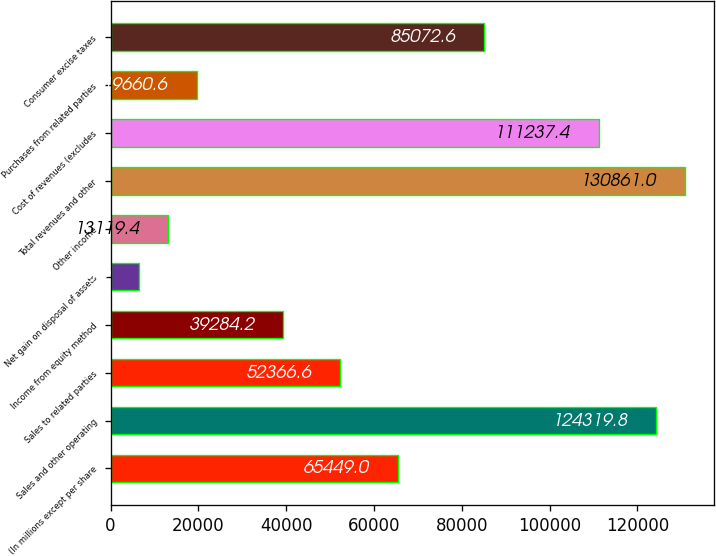Convert chart to OTSL. <chart><loc_0><loc_0><loc_500><loc_500><bar_chart><fcel>(In millions except per share<fcel>Sales and other operating<fcel>Sales to related parties<fcel>Income from equity method<fcel>Net gain on disposal of assets<fcel>Other income<fcel>Total revenues and other<fcel>Cost of revenues (excludes<fcel>Purchases from related parties<fcel>Consumer excise taxes<nl><fcel>65449<fcel>124320<fcel>52366.6<fcel>39284.2<fcel>6578.2<fcel>13119.4<fcel>130861<fcel>111237<fcel>19660.6<fcel>85072.6<nl></chart> 